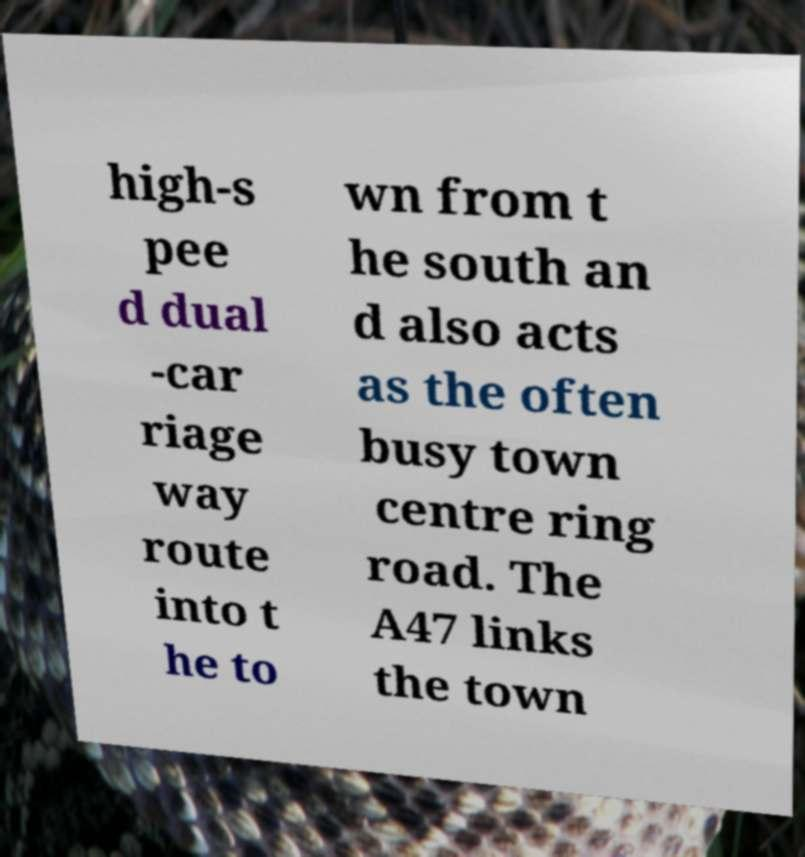There's text embedded in this image that I need extracted. Can you transcribe it verbatim? high-s pee d dual -car riage way route into t he to wn from t he south an d also acts as the often busy town centre ring road. The A47 links the town 